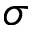Convert formula to latex. <formula><loc_0><loc_0><loc_500><loc_500>\sigma</formula> 